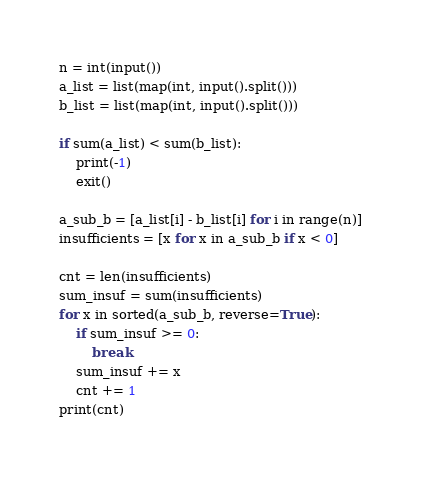Convert code to text. <code><loc_0><loc_0><loc_500><loc_500><_Python_>n = int(input())
a_list = list(map(int, input().split()))
b_list = list(map(int, input().split()))

if sum(a_list) < sum(b_list):
    print(-1)
    exit()

a_sub_b = [a_list[i] - b_list[i] for i in range(n)]
insufficients = [x for x in a_sub_b if x < 0]

cnt = len(insufficients)
sum_insuf = sum(insufficients)
for x in sorted(a_sub_b, reverse=True):
    if sum_insuf >= 0:
        break
    sum_insuf += x
    cnt += 1
print(cnt)
</code> 